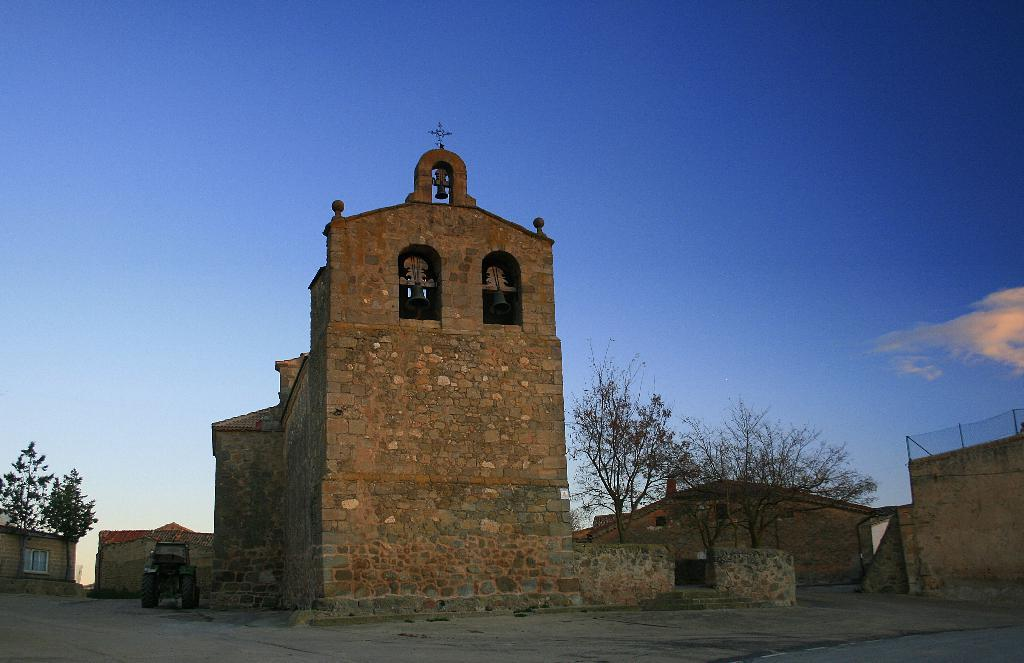What type of structures are present in the image? There are buildings in the image. What feature do the buildings have? The buildings have bells. Can you describe the location of a specific window in the image? There is a window in one of the buildings, and it is located at the left backdrop of the image. What type of vegetation is visible in the image? There are trees in the image. How would you describe the weather based on the image? The sky is clear in the image, suggesting good weather. What is the weight of the station visible in the image? There is no station present in the image; it features buildings with bells, a window, trees, and a clear sky. 